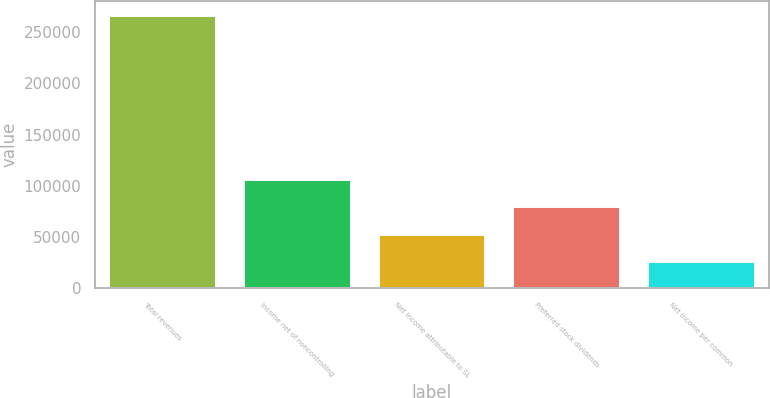<chart> <loc_0><loc_0><loc_500><loc_500><bar_chart><fcel>Total revenues<fcel>Income net of noncontrolling<fcel>Net income attributable to SL<fcel>Preferred stock dividends<fcel>Net income per common<nl><fcel>267245<fcel>106898<fcel>53449.1<fcel>80173.6<fcel>26724.6<nl></chart> 